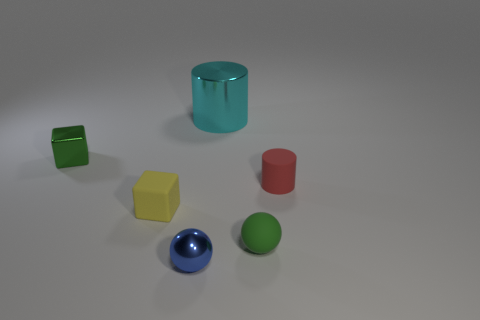How many small green balls are in front of the tiny rubber cylinder that is right of the tiny metallic thing that is to the right of the tiny yellow cube?
Offer a very short reply. 1. There is another thing that is the same shape as the red object; what is its size?
Provide a short and direct response. Large. Is there anything else that is the same size as the cyan thing?
Provide a succinct answer. No. Are there fewer small yellow objects to the right of the metal cylinder than small green matte objects?
Give a very brief answer. Yes. Is the tiny red rubber object the same shape as the large cyan object?
Give a very brief answer. Yes. What color is the other object that is the same shape as the small green metal object?
Your answer should be very brief. Yellow. How many small metallic things are the same color as the rubber ball?
Offer a very short reply. 1. What number of things are either cylinders that are behind the tiny red cylinder or blue metallic things?
Your answer should be very brief. 2. There is a cylinder behind the tiny red matte object; how big is it?
Provide a short and direct response. Large. Are there fewer small green cylinders than tiny metallic things?
Your answer should be compact. Yes. 